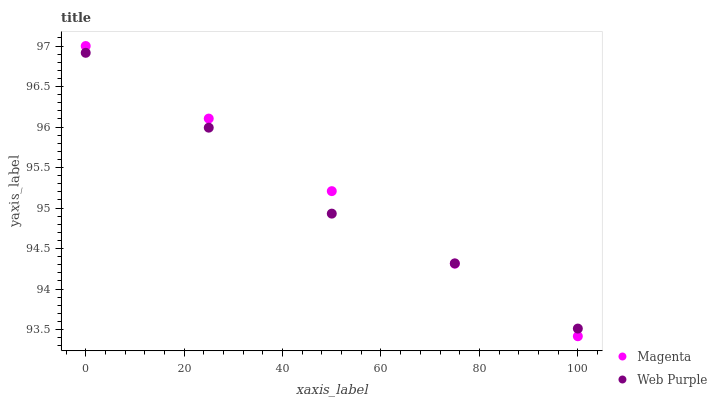Does Web Purple have the minimum area under the curve?
Answer yes or no. Yes. Does Magenta have the maximum area under the curve?
Answer yes or no. Yes. Does Web Purple have the maximum area under the curve?
Answer yes or no. No. Is Magenta the smoothest?
Answer yes or no. Yes. Is Web Purple the roughest?
Answer yes or no. Yes. Is Web Purple the smoothest?
Answer yes or no. No. Does Magenta have the lowest value?
Answer yes or no. Yes. Does Web Purple have the lowest value?
Answer yes or no. No. Does Magenta have the highest value?
Answer yes or no. Yes. Does Web Purple have the highest value?
Answer yes or no. No. Does Web Purple intersect Magenta?
Answer yes or no. Yes. Is Web Purple less than Magenta?
Answer yes or no. No. Is Web Purple greater than Magenta?
Answer yes or no. No. 